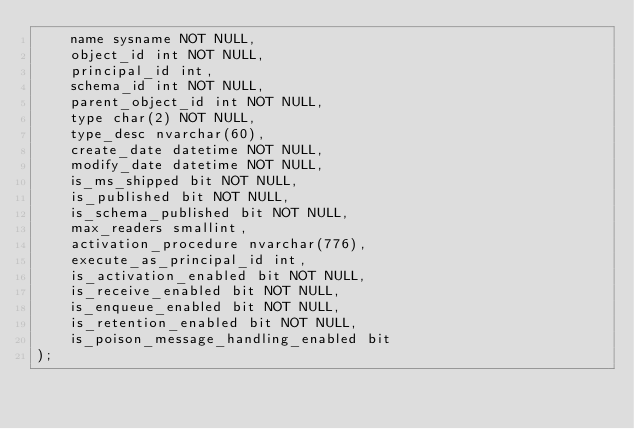<code> <loc_0><loc_0><loc_500><loc_500><_SQL_>    name sysname NOT NULL,
    object_id int NOT NULL,
    principal_id int,
    schema_id int NOT NULL,
    parent_object_id int NOT NULL,
    type char(2) NOT NULL,
    type_desc nvarchar(60),
    create_date datetime NOT NULL,
    modify_date datetime NOT NULL,
    is_ms_shipped bit NOT NULL,
    is_published bit NOT NULL,
    is_schema_published bit NOT NULL,
    max_readers smallint,
    activation_procedure nvarchar(776),
    execute_as_principal_id int,
    is_activation_enabled bit NOT NULL,
    is_receive_enabled bit NOT NULL,
    is_enqueue_enabled bit NOT NULL,
    is_retention_enabled bit NOT NULL,
    is_poison_message_handling_enabled bit
);</code> 